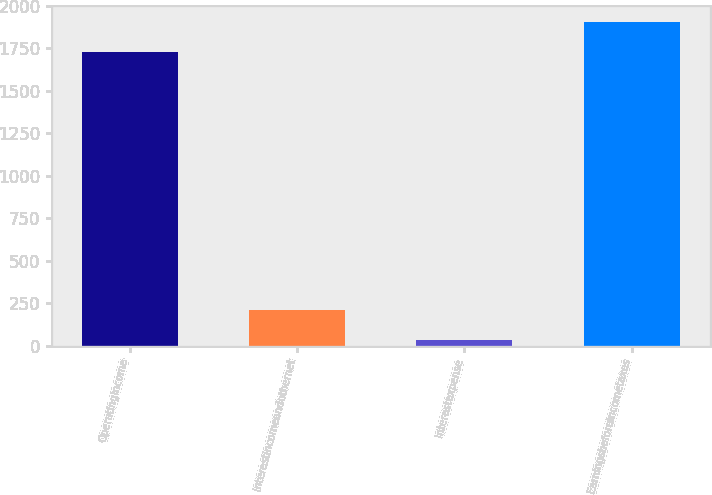Convert chart to OTSL. <chart><loc_0><loc_0><loc_500><loc_500><bar_chart><fcel>Operatingincome<fcel>Interestincomeandothernet<fcel>Interestexpense<fcel>Earningsbeforeincometaxes<nl><fcel>1728.5<fcel>211.08<fcel>33.3<fcel>1906.28<nl></chart> 